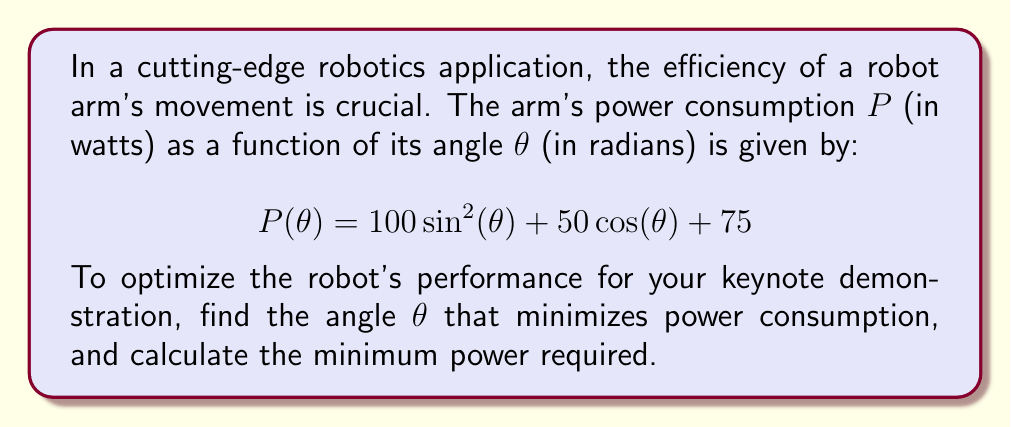Could you help me with this problem? To find the minimum power consumption, we need to find the angle $\theta$ where the derivative of $P(\theta)$ equals zero.

1) First, let's find the derivative of $P(\theta)$:

   $$\frac{d}{d\theta}P(\theta) = 200\sin(\theta)\cos(\theta) - 50\sin(\theta)$$
   
   $$P'(\theta) = 50\sin(\theta)(4\cos(\theta) - 1)$$

2) Set the derivative equal to zero and solve for $\theta$:

   $$50\sin(\theta)(4\cos(\theta) - 1) = 0$$

   This equation is satisfied when either $\sin(\theta) = 0$ or $4\cos(\theta) - 1 = 0$

3) Case 1: $\sin(\theta) = 0$
   This occurs when $\theta = 0, \pi, 2\pi, ...$

4) Case 2: $4\cos(\theta) - 1 = 0$
   $$\cos(\theta) = \frac{1}{4}$$
   $$\theta = \arccos(\frac{1}{4}) \approx 1.3181 \text{ radians}$$

5) To determine which of these critical points gives the minimum, we need to evaluate $P(\theta)$ at each point:

   At $\theta = 0$: $P(0) = 50 + 75 = 125$ watts
   At $\theta = \pi$: $P(\pi) = -50 + 75 = 25$ watts
   At $\theta = \arccos(\frac{1}{4})$: 
   $$P(\arccos(\frac{1}{4})) = 100(\frac{15}{16}) + 50(\frac{1}{4}) + 75 = 168.75 \text{ watts}$$

6) The minimum power consumption occurs at $\theta = \pi$ radians, with a power consumption of 25 watts.
Answer: $\theta = \pi$ radians, $P_{min} = 25$ watts 